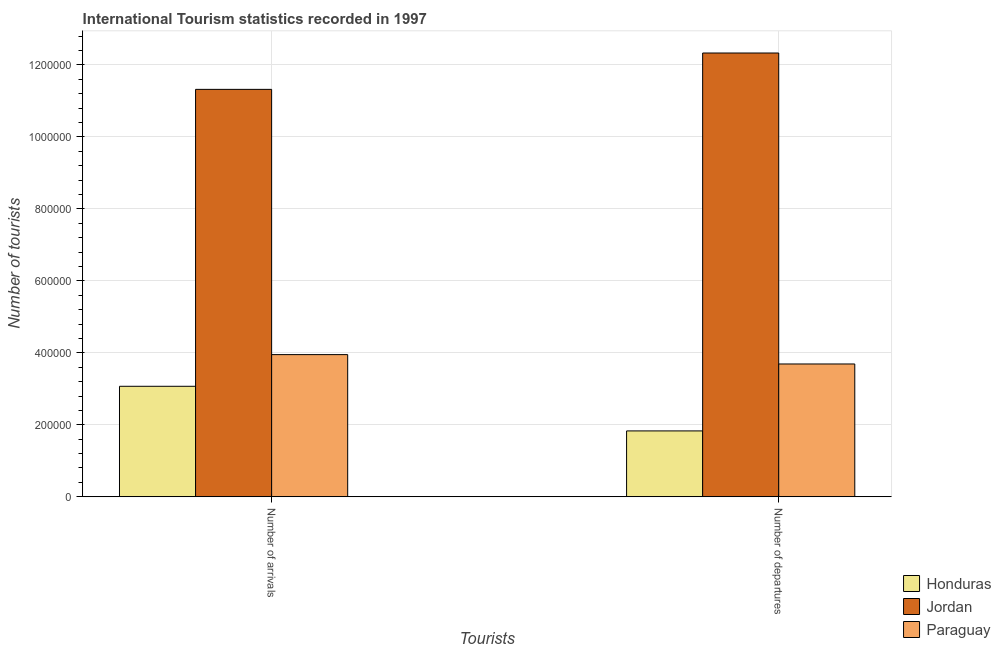How many different coloured bars are there?
Provide a short and direct response. 3. Are the number of bars per tick equal to the number of legend labels?
Give a very brief answer. Yes. Are the number of bars on each tick of the X-axis equal?
Keep it short and to the point. Yes. How many bars are there on the 1st tick from the left?
Give a very brief answer. 3. What is the label of the 1st group of bars from the left?
Your answer should be compact. Number of arrivals. What is the number of tourist arrivals in Paraguay?
Give a very brief answer. 3.95e+05. Across all countries, what is the maximum number of tourist departures?
Your answer should be compact. 1.23e+06. Across all countries, what is the minimum number of tourist arrivals?
Offer a very short reply. 3.07e+05. In which country was the number of tourist departures maximum?
Offer a terse response. Jordan. In which country was the number of tourist arrivals minimum?
Offer a very short reply. Honduras. What is the total number of tourist departures in the graph?
Offer a very short reply. 1.78e+06. What is the difference between the number of tourist departures in Honduras and that in Paraguay?
Provide a short and direct response. -1.86e+05. What is the difference between the number of tourist arrivals in Honduras and the number of tourist departures in Paraguay?
Ensure brevity in your answer.  -6.20e+04. What is the average number of tourist arrivals per country?
Offer a very short reply. 6.11e+05. What is the difference between the number of tourist arrivals and number of tourist departures in Paraguay?
Your answer should be compact. 2.60e+04. In how many countries, is the number of tourist arrivals greater than 1160000 ?
Keep it short and to the point. 0. What is the ratio of the number of tourist departures in Jordan to that in Honduras?
Offer a terse response. 6.74. Is the number of tourist arrivals in Jordan less than that in Paraguay?
Offer a terse response. No. In how many countries, is the number of tourist departures greater than the average number of tourist departures taken over all countries?
Make the answer very short. 1. What does the 3rd bar from the left in Number of departures represents?
Ensure brevity in your answer.  Paraguay. What does the 3rd bar from the right in Number of arrivals represents?
Your answer should be compact. Honduras. Are all the bars in the graph horizontal?
Keep it short and to the point. No. Does the graph contain grids?
Your response must be concise. Yes. How are the legend labels stacked?
Make the answer very short. Vertical. What is the title of the graph?
Ensure brevity in your answer.  International Tourism statistics recorded in 1997. Does "Cambodia" appear as one of the legend labels in the graph?
Make the answer very short. No. What is the label or title of the X-axis?
Offer a very short reply. Tourists. What is the label or title of the Y-axis?
Ensure brevity in your answer.  Number of tourists. What is the Number of tourists in Honduras in Number of arrivals?
Provide a succinct answer. 3.07e+05. What is the Number of tourists in Jordan in Number of arrivals?
Provide a succinct answer. 1.13e+06. What is the Number of tourists of Paraguay in Number of arrivals?
Your answer should be very brief. 3.95e+05. What is the Number of tourists of Honduras in Number of departures?
Provide a short and direct response. 1.83e+05. What is the Number of tourists of Jordan in Number of departures?
Your answer should be compact. 1.23e+06. What is the Number of tourists in Paraguay in Number of departures?
Your answer should be compact. 3.69e+05. Across all Tourists, what is the maximum Number of tourists of Honduras?
Give a very brief answer. 3.07e+05. Across all Tourists, what is the maximum Number of tourists in Jordan?
Provide a succinct answer. 1.23e+06. Across all Tourists, what is the maximum Number of tourists of Paraguay?
Offer a terse response. 3.95e+05. Across all Tourists, what is the minimum Number of tourists in Honduras?
Your answer should be very brief. 1.83e+05. Across all Tourists, what is the minimum Number of tourists of Jordan?
Provide a short and direct response. 1.13e+06. Across all Tourists, what is the minimum Number of tourists of Paraguay?
Make the answer very short. 3.69e+05. What is the total Number of tourists of Jordan in the graph?
Give a very brief answer. 2.36e+06. What is the total Number of tourists of Paraguay in the graph?
Provide a succinct answer. 7.64e+05. What is the difference between the Number of tourists in Honduras in Number of arrivals and that in Number of departures?
Make the answer very short. 1.24e+05. What is the difference between the Number of tourists of Jordan in Number of arrivals and that in Number of departures?
Offer a terse response. -1.01e+05. What is the difference between the Number of tourists in Paraguay in Number of arrivals and that in Number of departures?
Give a very brief answer. 2.60e+04. What is the difference between the Number of tourists of Honduras in Number of arrivals and the Number of tourists of Jordan in Number of departures?
Provide a short and direct response. -9.26e+05. What is the difference between the Number of tourists of Honduras in Number of arrivals and the Number of tourists of Paraguay in Number of departures?
Your answer should be compact. -6.20e+04. What is the difference between the Number of tourists of Jordan in Number of arrivals and the Number of tourists of Paraguay in Number of departures?
Offer a very short reply. 7.63e+05. What is the average Number of tourists of Honduras per Tourists?
Give a very brief answer. 2.45e+05. What is the average Number of tourists in Jordan per Tourists?
Your response must be concise. 1.18e+06. What is the average Number of tourists in Paraguay per Tourists?
Offer a very short reply. 3.82e+05. What is the difference between the Number of tourists of Honduras and Number of tourists of Jordan in Number of arrivals?
Your answer should be very brief. -8.25e+05. What is the difference between the Number of tourists in Honduras and Number of tourists in Paraguay in Number of arrivals?
Your response must be concise. -8.80e+04. What is the difference between the Number of tourists of Jordan and Number of tourists of Paraguay in Number of arrivals?
Ensure brevity in your answer.  7.37e+05. What is the difference between the Number of tourists of Honduras and Number of tourists of Jordan in Number of departures?
Make the answer very short. -1.05e+06. What is the difference between the Number of tourists in Honduras and Number of tourists in Paraguay in Number of departures?
Keep it short and to the point. -1.86e+05. What is the difference between the Number of tourists of Jordan and Number of tourists of Paraguay in Number of departures?
Keep it short and to the point. 8.64e+05. What is the ratio of the Number of tourists in Honduras in Number of arrivals to that in Number of departures?
Make the answer very short. 1.68. What is the ratio of the Number of tourists in Jordan in Number of arrivals to that in Number of departures?
Provide a succinct answer. 0.92. What is the ratio of the Number of tourists in Paraguay in Number of arrivals to that in Number of departures?
Ensure brevity in your answer.  1.07. What is the difference between the highest and the second highest Number of tourists in Honduras?
Your answer should be compact. 1.24e+05. What is the difference between the highest and the second highest Number of tourists of Jordan?
Your answer should be compact. 1.01e+05. What is the difference between the highest and the second highest Number of tourists of Paraguay?
Offer a terse response. 2.60e+04. What is the difference between the highest and the lowest Number of tourists in Honduras?
Provide a succinct answer. 1.24e+05. What is the difference between the highest and the lowest Number of tourists in Jordan?
Your response must be concise. 1.01e+05. What is the difference between the highest and the lowest Number of tourists of Paraguay?
Give a very brief answer. 2.60e+04. 